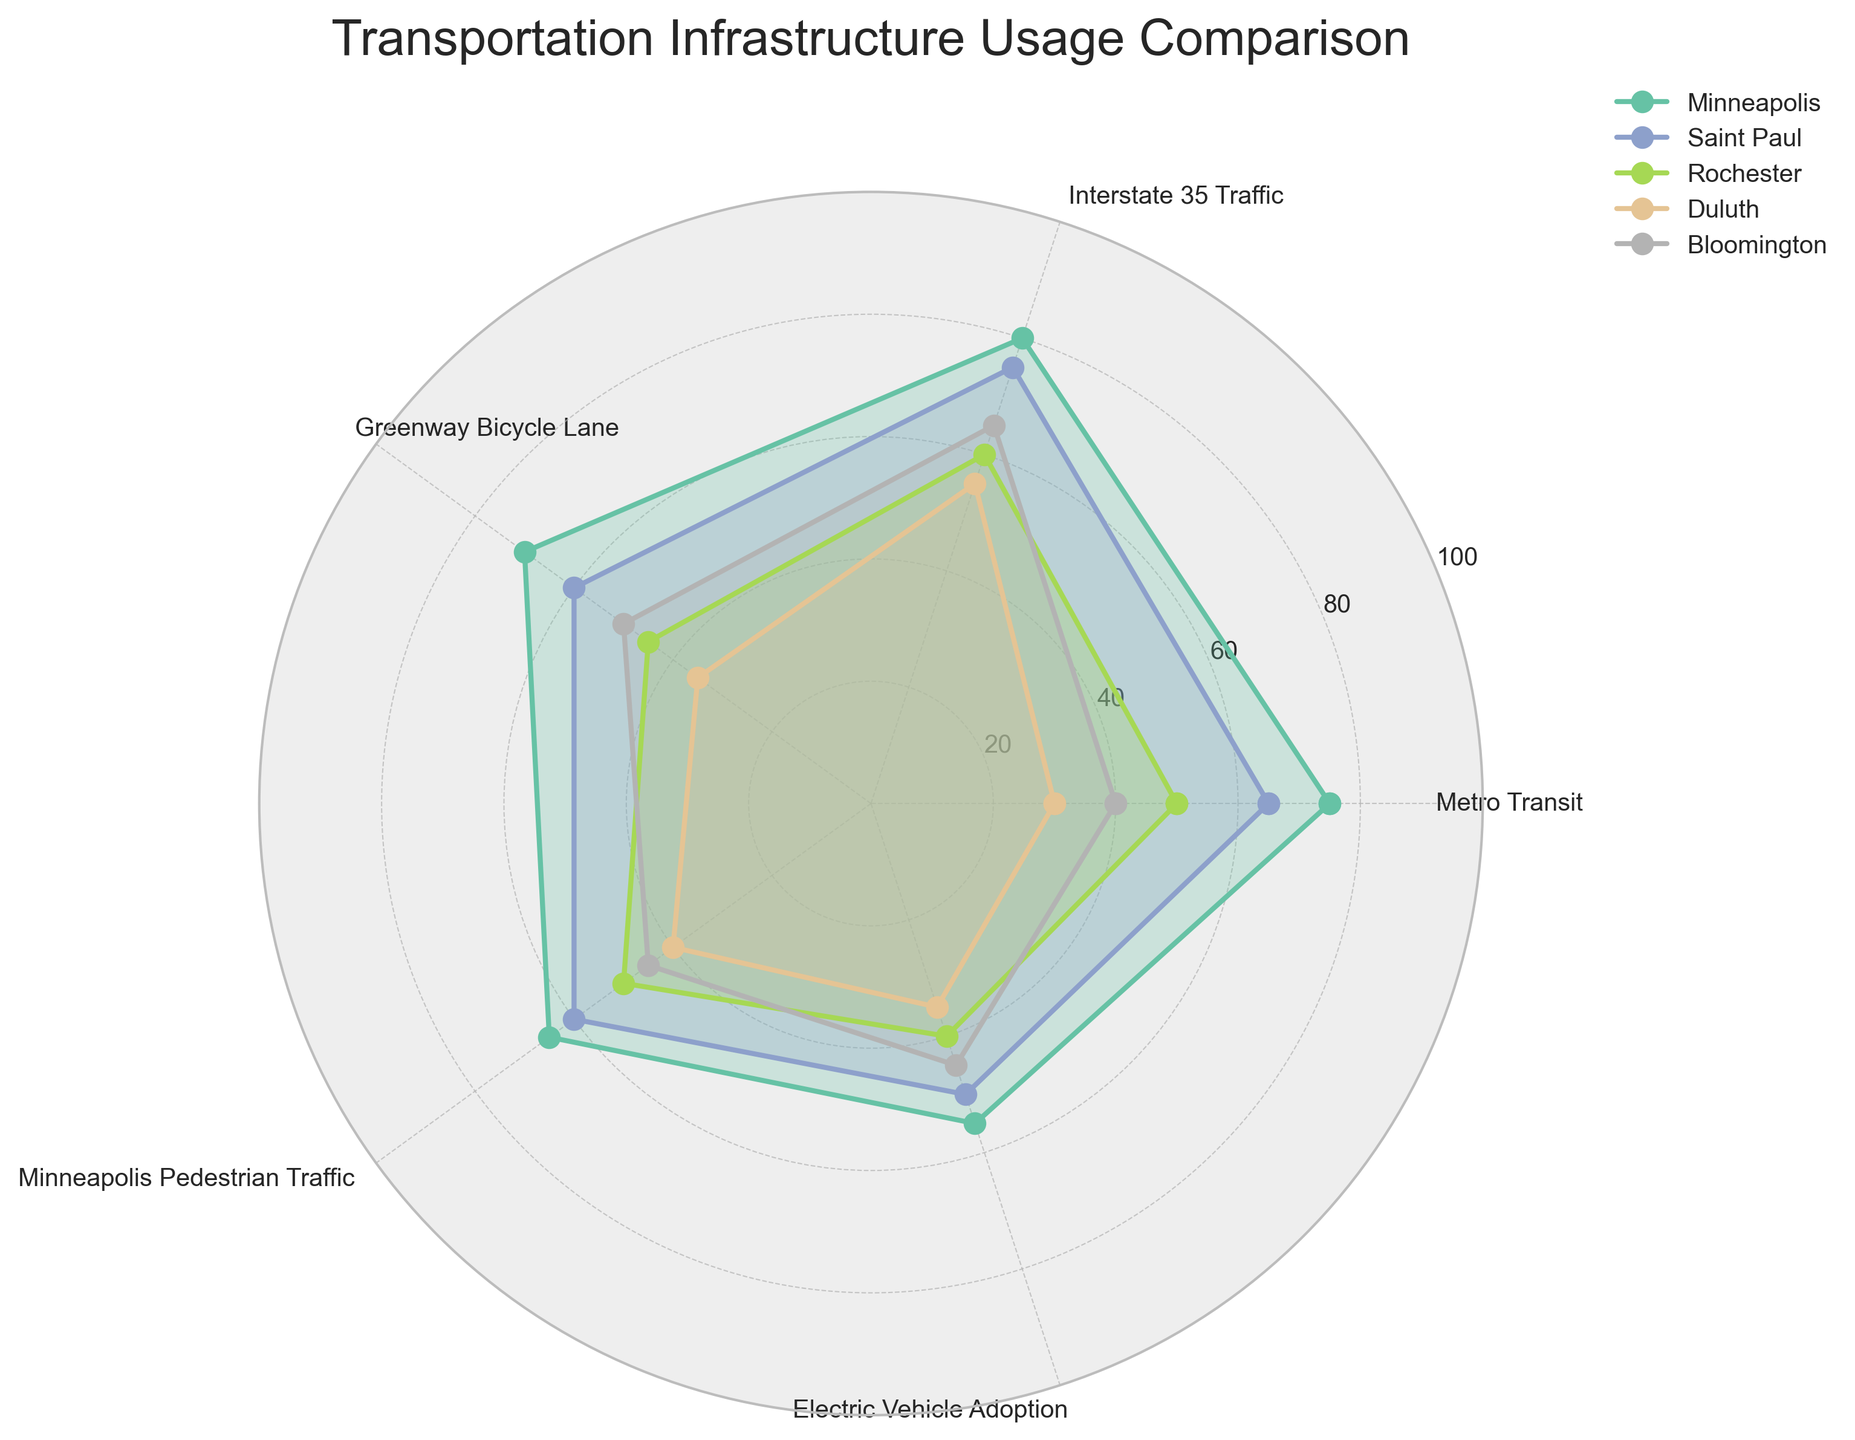What is the title of the radar chart? The title of the chart can be found at the top of the figure. It usually provides a quick understanding of what the chart is about.
Answer: Transportation Infrastructure Usage Comparison Which city has the highest Metro Transit usage? Examine the values on the radar chart for the Metro Transit category and identify the city with the highest value.
Answer: Minneapolis Which city has the lowest Electric Vehicle Adoption? Locate the values in the Electric Vehicle Adoption category on the radar chart and find the city with the smallest value.
Answer: Duluth What is the average value of Interstate 35 Traffic across all cities? Add up the values of Interstate 35 Traffic for all cities and divide by the number of cities. (80 + 75 + 60 + 55 + 65) / 5 = 335 / 5 = 67
Answer: 67 What is the difference in Greenway Bicycle Lane utilization between Minneapolis and Rochester? Subtract the value for Rochester from the value for Minneapolis in the Greenway Bicycle Lane category. 70 - 45 = 25
Answer: 25 Between Bloomington and Duluth, which city showcases higher Minneapolis Pedestrian Traffic, and by how much? Compare the values of Minneapolis Pedestrian Traffic for Bloomington and Duluth and calculate the difference. 45 - 40 = 5
Answer: Bloomington by 5 In terms of Public Transit Ridership, how does Saint Paul compare to Rochester? Look at the Metro Transit values for both cities. Saint Paul has a value of 65, and Rochester has a value of 50; 65 > 50.
Answer: Saint Paul has higher ridership Which city has the most balanced utilization across all categories? Evaluate the radar plot for each city to determine which one has the most even spread across all categories.
Answer: Bloomington Rank the cities from highest to lowest in terms of Pedestrian Traffic. Compare the values in the Minneapolis Pedestrian Traffic category for all cities and rank them accordingly: 65 (Minneapolis), 60 (Saint Paul), 50 (Rochester), 45 (Bloomington), 40 (Duluth)
Answer: Minneapolis, Saint Paul, Rochester, Bloomington, Duluth 